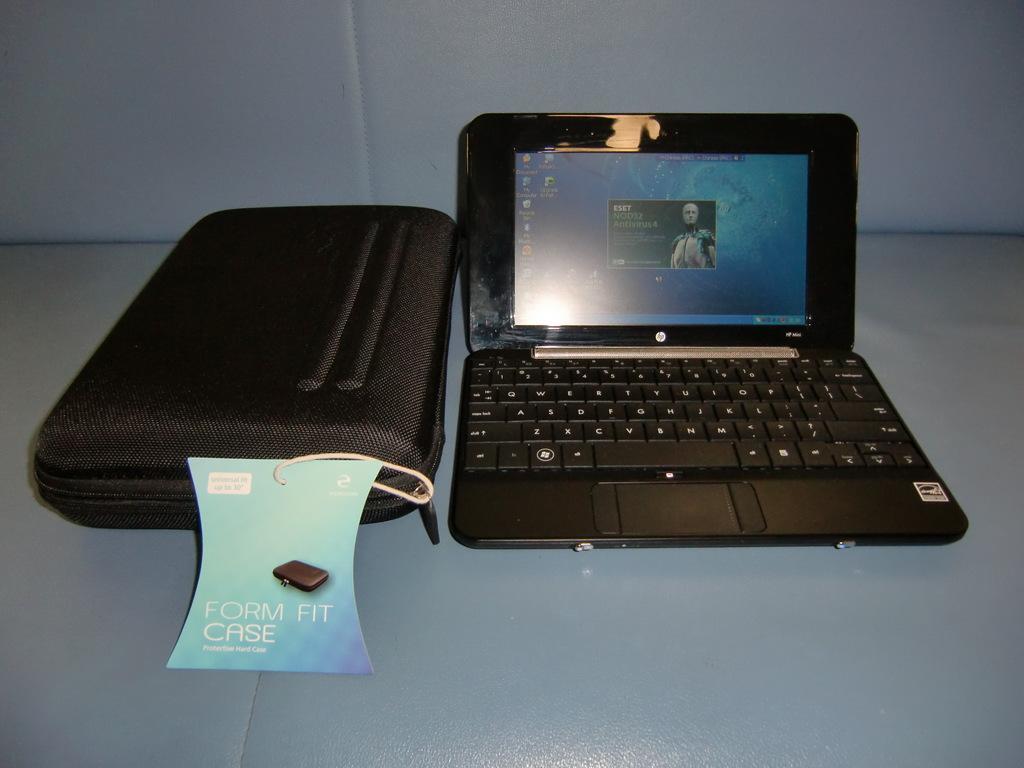Describe this image in one or two sentences. In this image we can see a laptop and a case placed on the surface. 